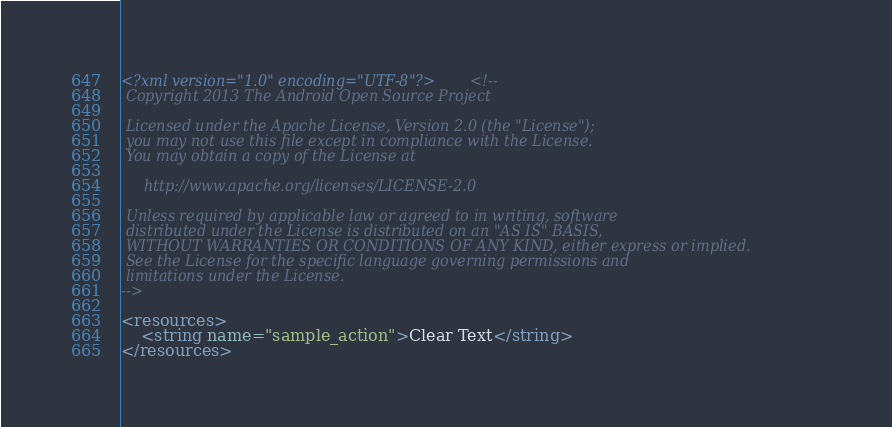Convert code to text. <code><loc_0><loc_0><loc_500><loc_500><_XML_><?xml version="1.0" encoding="UTF-8"?><!--
 Copyright 2013 The Android Open Source Project

 Licensed under the Apache License, Version 2.0 (the "License");
 you may not use this file except in compliance with the License.
 You may obtain a copy of the License at

     http://www.apache.org/licenses/LICENSE-2.0

 Unless required by applicable law or agreed to in writing, software
 distributed under the License is distributed on an "AS IS" BASIS,
 WITHOUT WARRANTIES OR CONDITIONS OF ANY KIND, either express or implied.
 See the License for the specific language governing permissions and
 limitations under the License.
-->

<resources>
    <string name="sample_action">Clear Text</string>
</resources>
</code> 